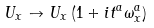<formula> <loc_0><loc_0><loc_500><loc_500>U _ { x } \to U _ { x } \left ( 1 + i t ^ { a } \omega ^ { a } _ { x } \right )</formula> 